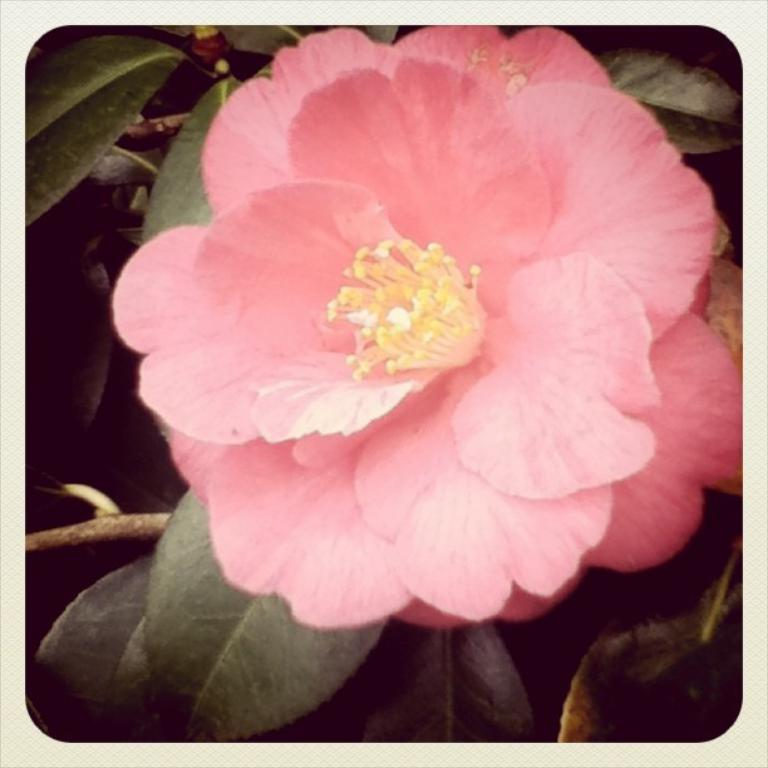What type of editing has been done to the image? The image is edited, but the specific type of editing is not mentioned in the facts. What is the main subject of the image? The main subject of the image is a flower. Can you describe the flower in the image? The flower has a stem and leaves. Where is the flower located in the image? The flower is in the middle of the image. What type of light is shining on the flower in the image? There is no mention of light shining on the flower in the image, so we cannot answer this question. Is the flower in the image being held in a jail cell? There is no indication of a jail cell or any confinement in the image, so we cannot answer this question. 